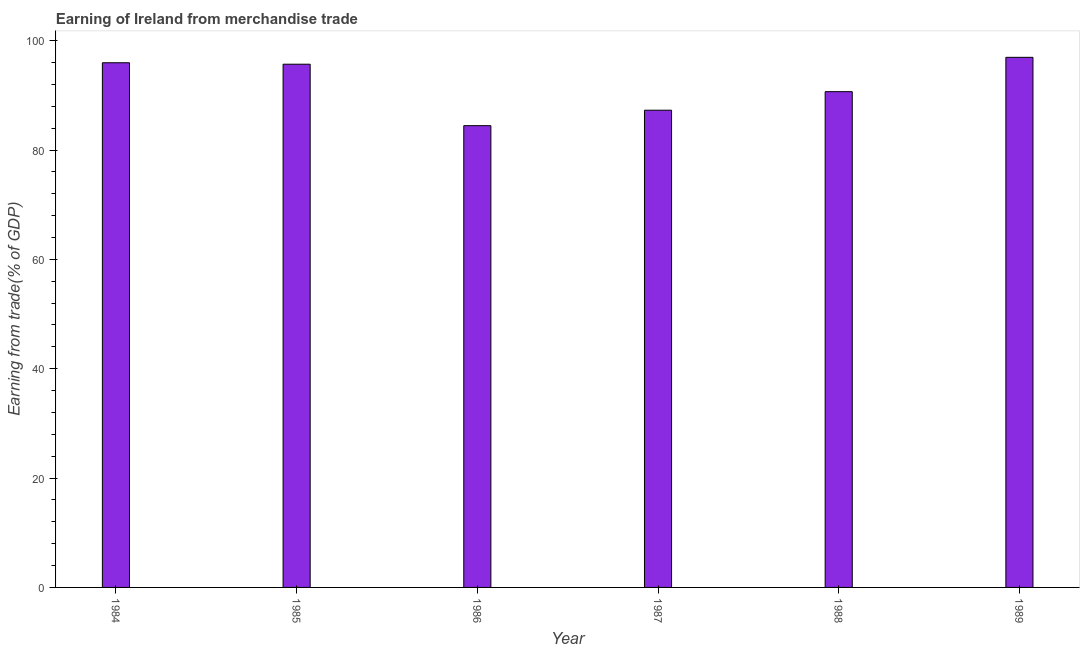Does the graph contain grids?
Ensure brevity in your answer.  No. What is the title of the graph?
Offer a terse response. Earning of Ireland from merchandise trade. What is the label or title of the X-axis?
Give a very brief answer. Year. What is the label or title of the Y-axis?
Make the answer very short. Earning from trade(% of GDP). What is the earning from merchandise trade in 1984?
Make the answer very short. 95.96. Across all years, what is the maximum earning from merchandise trade?
Your answer should be compact. 96.96. Across all years, what is the minimum earning from merchandise trade?
Give a very brief answer. 84.46. What is the sum of the earning from merchandise trade?
Give a very brief answer. 551.04. What is the difference between the earning from merchandise trade in 1987 and 1988?
Make the answer very short. -3.39. What is the average earning from merchandise trade per year?
Ensure brevity in your answer.  91.84. What is the median earning from merchandise trade?
Your answer should be compact. 93.19. In how many years, is the earning from merchandise trade greater than 80 %?
Your answer should be very brief. 6. Do a majority of the years between 1986 and 1984 (inclusive) have earning from merchandise trade greater than 20 %?
Ensure brevity in your answer.  Yes. Is the earning from merchandise trade in 1985 less than that in 1988?
Offer a very short reply. No. What is the difference between the highest and the second highest earning from merchandise trade?
Your answer should be very brief. 0.99. What is the difference between the highest and the lowest earning from merchandise trade?
Provide a succinct answer. 12.5. How many bars are there?
Provide a short and direct response. 6. Are all the bars in the graph horizontal?
Make the answer very short. No. What is the difference between two consecutive major ticks on the Y-axis?
Provide a succinct answer. 20. Are the values on the major ticks of Y-axis written in scientific E-notation?
Ensure brevity in your answer.  No. What is the Earning from trade(% of GDP) in 1984?
Provide a short and direct response. 95.96. What is the Earning from trade(% of GDP) of 1985?
Your answer should be compact. 95.7. What is the Earning from trade(% of GDP) of 1986?
Your answer should be very brief. 84.46. What is the Earning from trade(% of GDP) of 1987?
Offer a terse response. 87.29. What is the Earning from trade(% of GDP) in 1988?
Offer a terse response. 90.68. What is the Earning from trade(% of GDP) in 1989?
Offer a terse response. 96.96. What is the difference between the Earning from trade(% of GDP) in 1984 and 1985?
Offer a terse response. 0.27. What is the difference between the Earning from trade(% of GDP) in 1984 and 1986?
Offer a very short reply. 11.51. What is the difference between the Earning from trade(% of GDP) in 1984 and 1987?
Your answer should be very brief. 8.68. What is the difference between the Earning from trade(% of GDP) in 1984 and 1988?
Your response must be concise. 5.29. What is the difference between the Earning from trade(% of GDP) in 1984 and 1989?
Your answer should be compact. -0.99. What is the difference between the Earning from trade(% of GDP) in 1985 and 1986?
Ensure brevity in your answer.  11.24. What is the difference between the Earning from trade(% of GDP) in 1985 and 1987?
Offer a very short reply. 8.41. What is the difference between the Earning from trade(% of GDP) in 1985 and 1988?
Ensure brevity in your answer.  5.02. What is the difference between the Earning from trade(% of GDP) in 1985 and 1989?
Keep it short and to the point. -1.26. What is the difference between the Earning from trade(% of GDP) in 1986 and 1987?
Make the answer very short. -2.83. What is the difference between the Earning from trade(% of GDP) in 1986 and 1988?
Offer a very short reply. -6.22. What is the difference between the Earning from trade(% of GDP) in 1986 and 1989?
Provide a succinct answer. -12.5. What is the difference between the Earning from trade(% of GDP) in 1987 and 1988?
Keep it short and to the point. -3.39. What is the difference between the Earning from trade(% of GDP) in 1987 and 1989?
Your answer should be very brief. -9.67. What is the difference between the Earning from trade(% of GDP) in 1988 and 1989?
Ensure brevity in your answer.  -6.28. What is the ratio of the Earning from trade(% of GDP) in 1984 to that in 1985?
Your answer should be compact. 1. What is the ratio of the Earning from trade(% of GDP) in 1984 to that in 1986?
Make the answer very short. 1.14. What is the ratio of the Earning from trade(% of GDP) in 1984 to that in 1987?
Keep it short and to the point. 1.1. What is the ratio of the Earning from trade(% of GDP) in 1984 to that in 1988?
Ensure brevity in your answer.  1.06. What is the ratio of the Earning from trade(% of GDP) in 1985 to that in 1986?
Your answer should be compact. 1.13. What is the ratio of the Earning from trade(% of GDP) in 1985 to that in 1987?
Your answer should be very brief. 1.1. What is the ratio of the Earning from trade(% of GDP) in 1985 to that in 1988?
Offer a terse response. 1.05. What is the ratio of the Earning from trade(% of GDP) in 1985 to that in 1989?
Give a very brief answer. 0.99. What is the ratio of the Earning from trade(% of GDP) in 1986 to that in 1988?
Offer a terse response. 0.93. What is the ratio of the Earning from trade(% of GDP) in 1986 to that in 1989?
Your response must be concise. 0.87. What is the ratio of the Earning from trade(% of GDP) in 1987 to that in 1989?
Ensure brevity in your answer.  0.9. What is the ratio of the Earning from trade(% of GDP) in 1988 to that in 1989?
Offer a terse response. 0.94. 